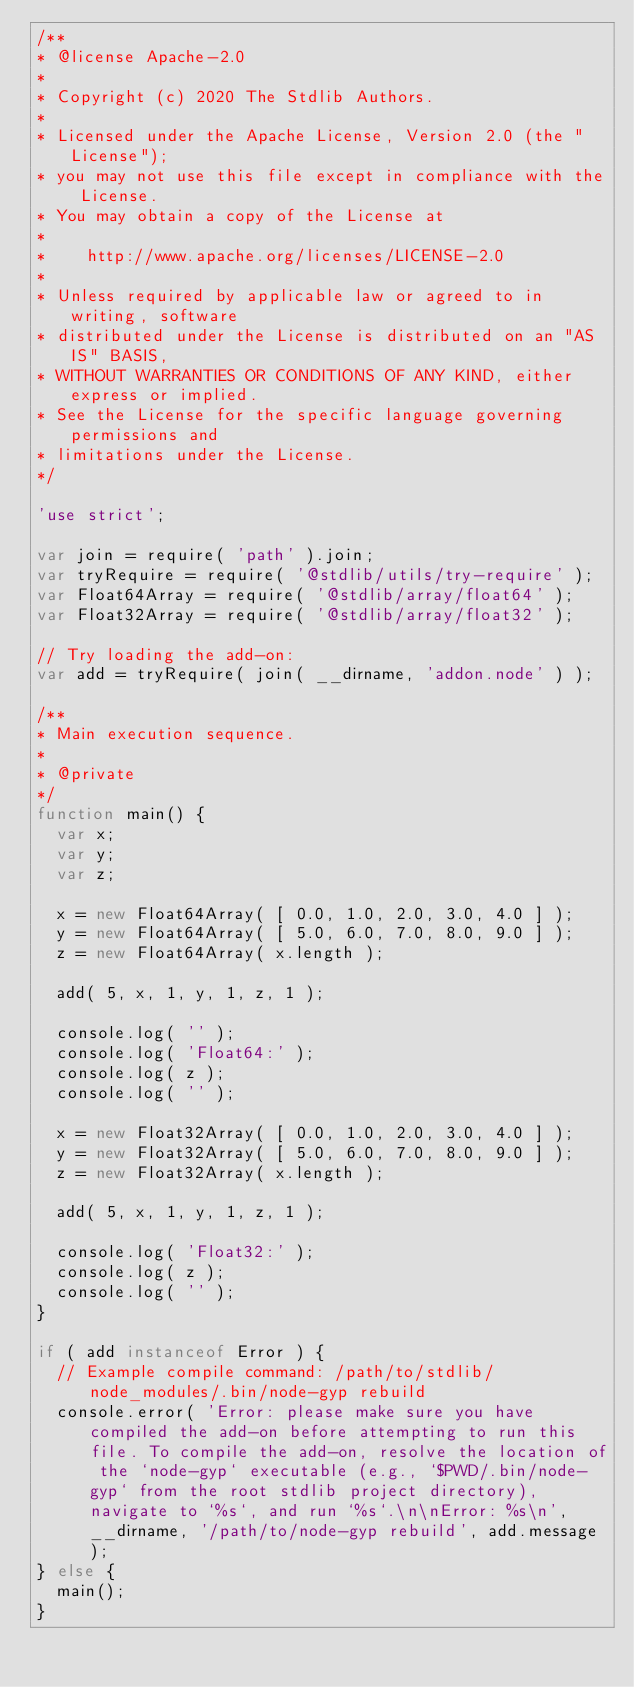Convert code to text. <code><loc_0><loc_0><loc_500><loc_500><_JavaScript_>/**
* @license Apache-2.0
*
* Copyright (c) 2020 The Stdlib Authors.
*
* Licensed under the Apache License, Version 2.0 (the "License");
* you may not use this file except in compliance with the License.
* You may obtain a copy of the License at
*
*    http://www.apache.org/licenses/LICENSE-2.0
*
* Unless required by applicable law or agreed to in writing, software
* distributed under the License is distributed on an "AS IS" BASIS,
* WITHOUT WARRANTIES OR CONDITIONS OF ANY KIND, either express or implied.
* See the License for the specific language governing permissions and
* limitations under the License.
*/

'use strict';

var join = require( 'path' ).join;
var tryRequire = require( '@stdlib/utils/try-require' );
var Float64Array = require( '@stdlib/array/float64' );
var Float32Array = require( '@stdlib/array/float32' );

// Try loading the add-on:
var add = tryRequire( join( __dirname, 'addon.node' ) );

/**
* Main execution sequence.
*
* @private
*/
function main() {
	var x;
	var y;
	var z;

	x = new Float64Array( [ 0.0, 1.0, 2.0, 3.0, 4.0 ] );
	y = new Float64Array( [ 5.0, 6.0, 7.0, 8.0, 9.0 ] );
	z = new Float64Array( x.length );

	add( 5, x, 1, y, 1, z, 1 );

	console.log( '' );
	console.log( 'Float64:' );
	console.log( z );
	console.log( '' );

	x = new Float32Array( [ 0.0, 1.0, 2.0, 3.0, 4.0 ] );
	y = new Float32Array( [ 5.0, 6.0, 7.0, 8.0, 9.0 ] );
	z = new Float32Array( x.length );

	add( 5, x, 1, y, 1, z, 1 );

	console.log( 'Float32:' );
	console.log( z );
	console.log( '' );
}

if ( add instanceof Error ) {
	// Example compile command: /path/to/stdlib/node_modules/.bin/node-gyp rebuild
	console.error( 'Error: please make sure you have compiled the add-on before attempting to run this file. To compile the add-on, resolve the location of the `node-gyp` executable (e.g., `$PWD/.bin/node-gyp` from the root stdlib project directory), navigate to `%s`, and run `%s`.\n\nError: %s\n', __dirname, '/path/to/node-gyp rebuild', add.message );
} else {
	main();
}
</code> 